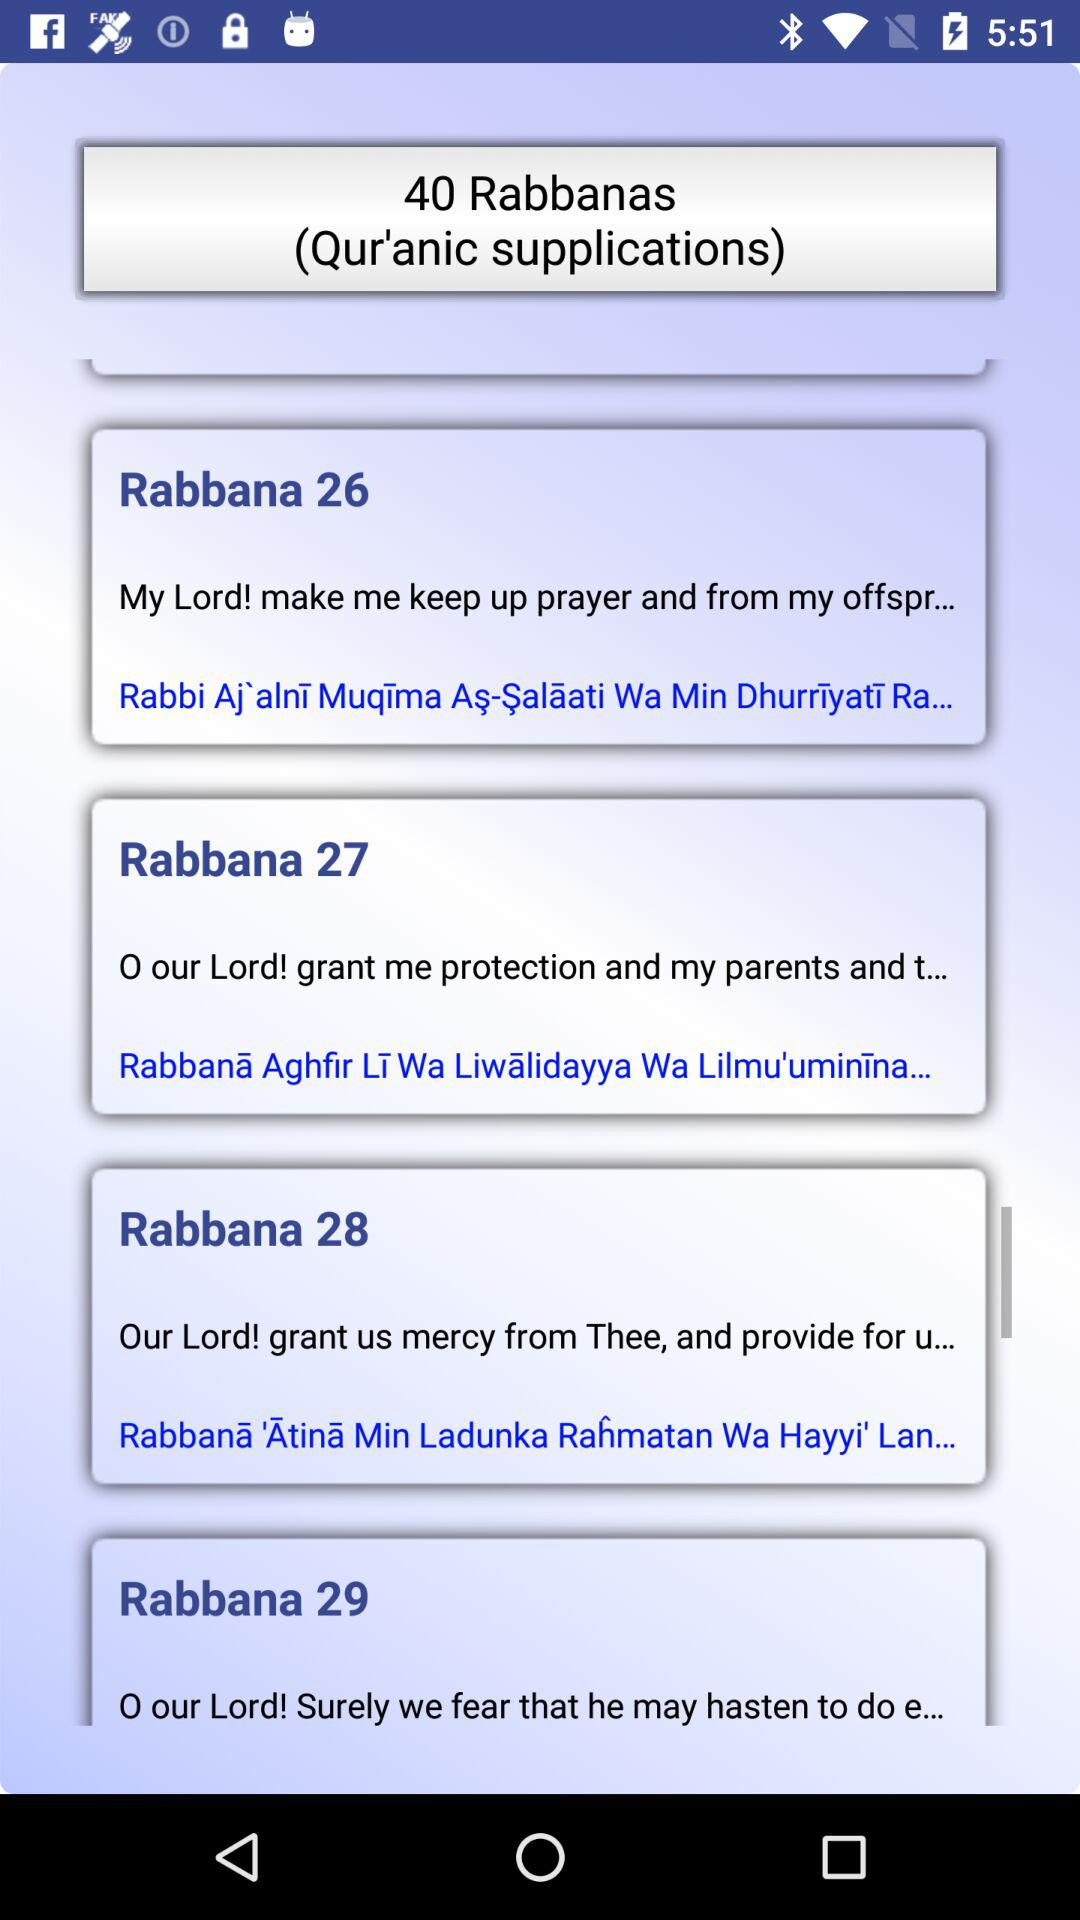What are the different Qur'anic supplications are there? The different Qur'anic supplications are "Rabbana 26", "Rabbana 27", "Rabbana 28" and "Rabbana 29". 